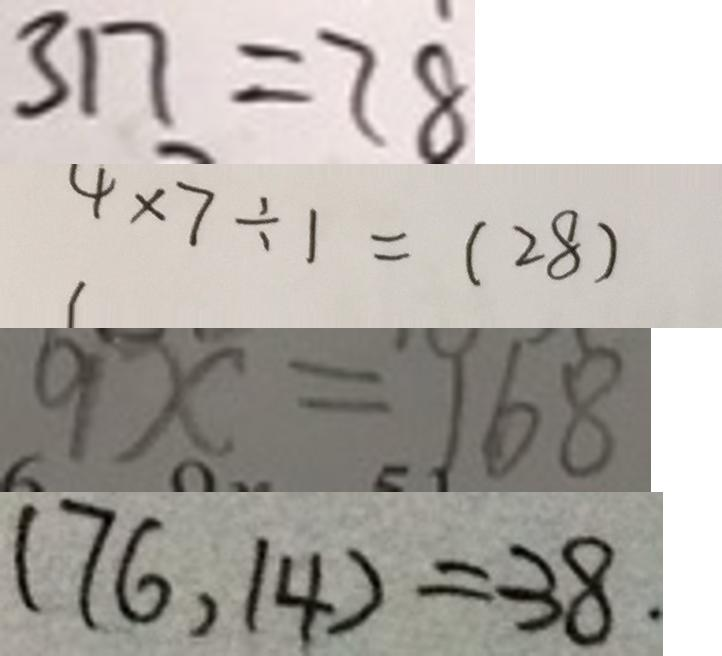Convert formula to latex. <formula><loc_0><loc_0><loc_500><loc_500>3 1 7 = 7 8 
 4 \times 7 \div 1 = ( 2 8 ) 
 9 x = 1 6 8 
 ( 7 6 , 1 4 ) = 3 8 .</formula> 